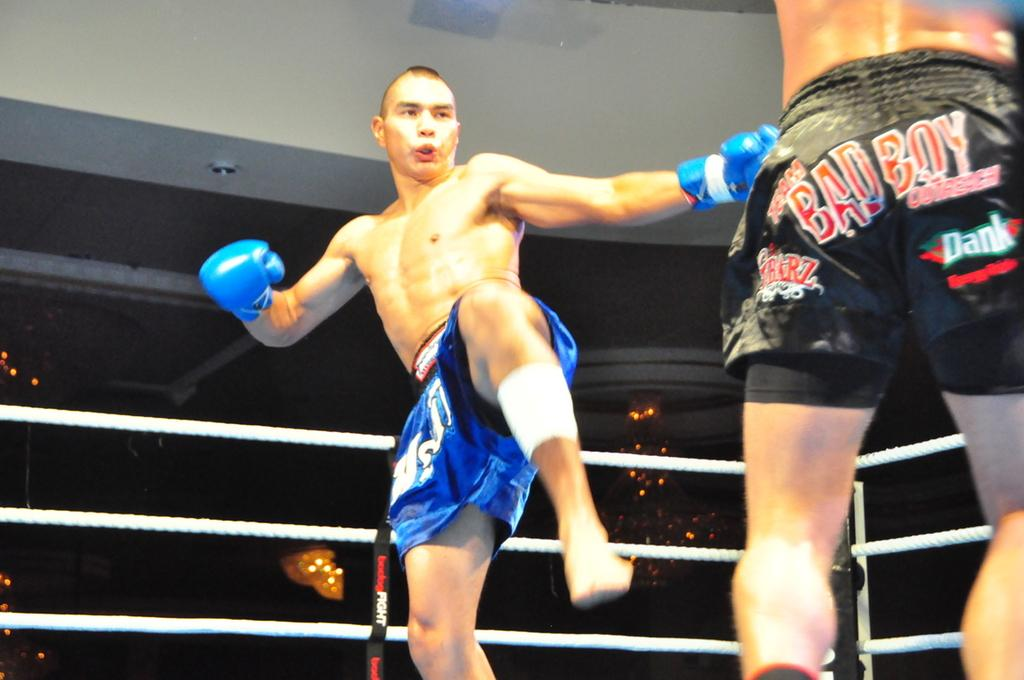<image>
Provide a brief description of the given image. A kickboxer in blue shorts aims a kick at his opponent who is wearing black shorts with BAD BOY written on them as well as sponsors names. 